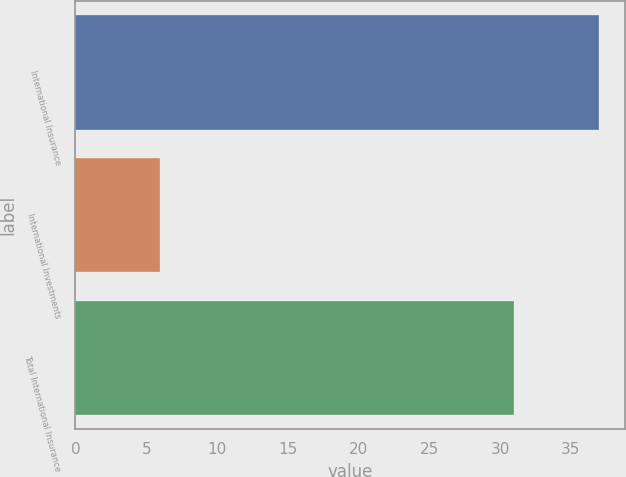Convert chart. <chart><loc_0><loc_0><loc_500><loc_500><bar_chart><fcel>International Insurance<fcel>International Investments<fcel>Total International Insurance<nl><fcel>37<fcel>6<fcel>31<nl></chart> 